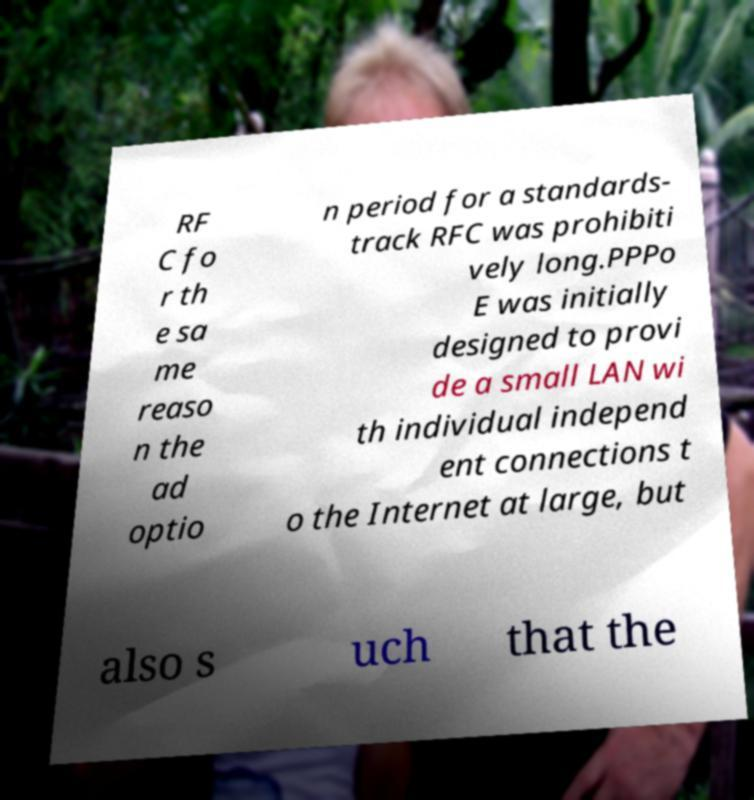Please read and relay the text visible in this image. What does it say? RF C fo r th e sa me reaso n the ad optio n period for a standards- track RFC was prohibiti vely long.PPPo E was initially designed to provi de a small LAN wi th individual independ ent connections t o the Internet at large, but also s uch that the 